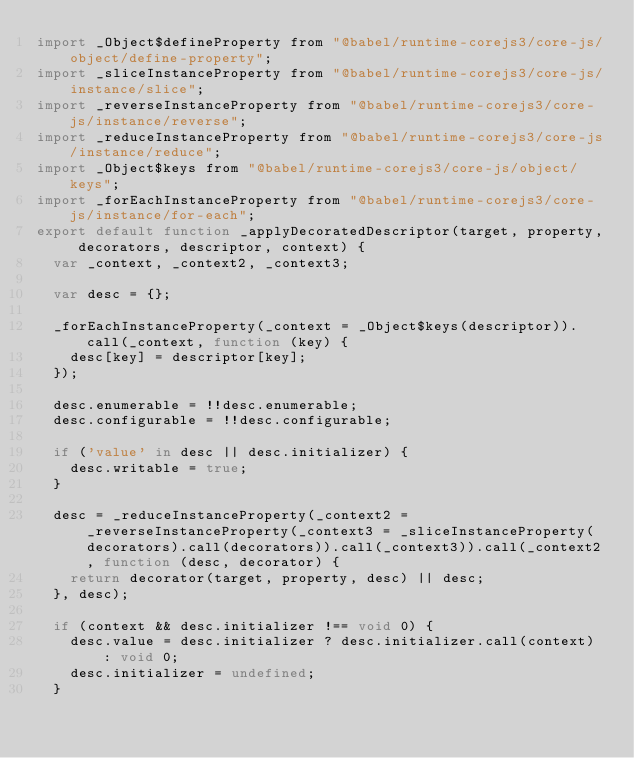<code> <loc_0><loc_0><loc_500><loc_500><_JavaScript_>import _Object$defineProperty from "@babel/runtime-corejs3/core-js/object/define-property";
import _sliceInstanceProperty from "@babel/runtime-corejs3/core-js/instance/slice";
import _reverseInstanceProperty from "@babel/runtime-corejs3/core-js/instance/reverse";
import _reduceInstanceProperty from "@babel/runtime-corejs3/core-js/instance/reduce";
import _Object$keys from "@babel/runtime-corejs3/core-js/object/keys";
import _forEachInstanceProperty from "@babel/runtime-corejs3/core-js/instance/for-each";
export default function _applyDecoratedDescriptor(target, property, decorators, descriptor, context) {
  var _context, _context2, _context3;

  var desc = {};

  _forEachInstanceProperty(_context = _Object$keys(descriptor)).call(_context, function (key) {
    desc[key] = descriptor[key];
  });

  desc.enumerable = !!desc.enumerable;
  desc.configurable = !!desc.configurable;

  if ('value' in desc || desc.initializer) {
    desc.writable = true;
  }

  desc = _reduceInstanceProperty(_context2 = _reverseInstanceProperty(_context3 = _sliceInstanceProperty(decorators).call(decorators)).call(_context3)).call(_context2, function (desc, decorator) {
    return decorator(target, property, desc) || desc;
  }, desc);

  if (context && desc.initializer !== void 0) {
    desc.value = desc.initializer ? desc.initializer.call(context) : void 0;
    desc.initializer = undefined;
  }
</code> 